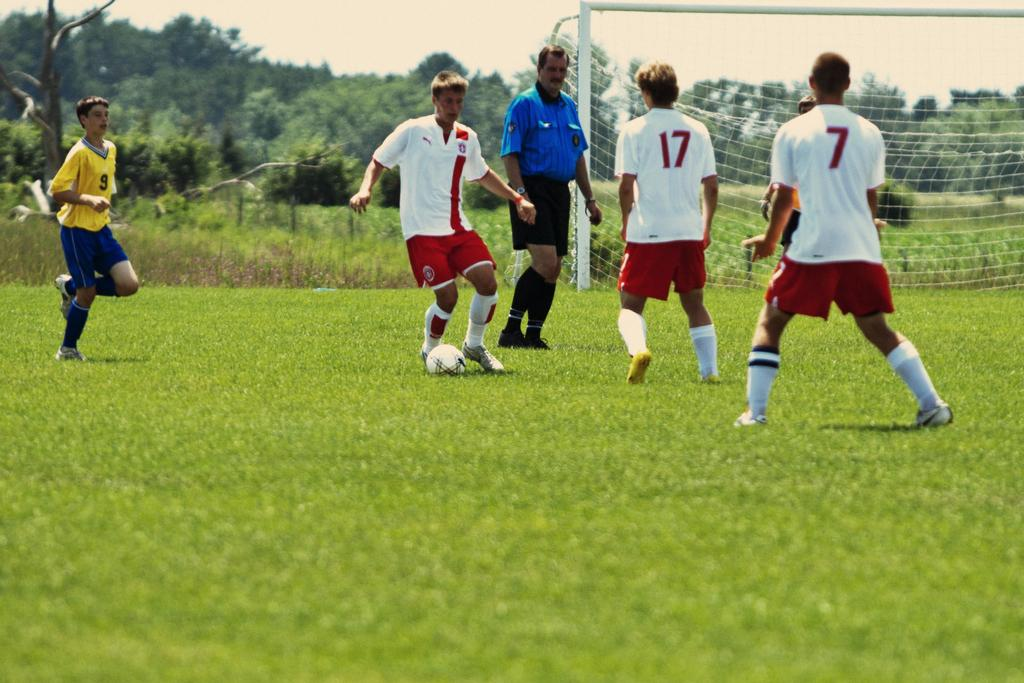Where was the image taken? The image is taken outdoors. What activity are the people engaged in? There is a group of people playing football. What is the purpose of the net behind the people? The net is likely used to mark the boundaries of the playing area or to catch the ball. What can be seen in the background of the image? Trees are visible in the background. What type of industry can be seen in the background of the image? There is no industry visible in the background of the image; it features trees instead. How does the heat affect the people playing football in the image? The image does not provide any information about the temperature or weather conditions, so it is impossible to determine how the heat might affect the people playing football. 